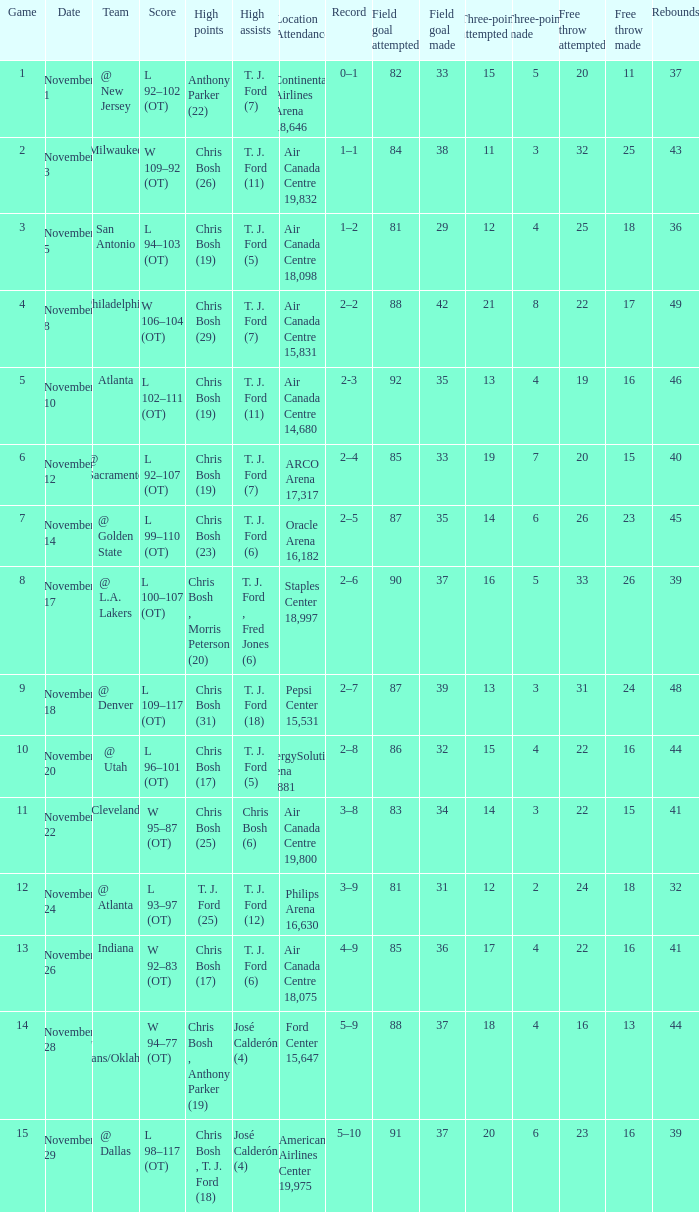What team played on November 28? @ New Orleans/Oklahoma City. 